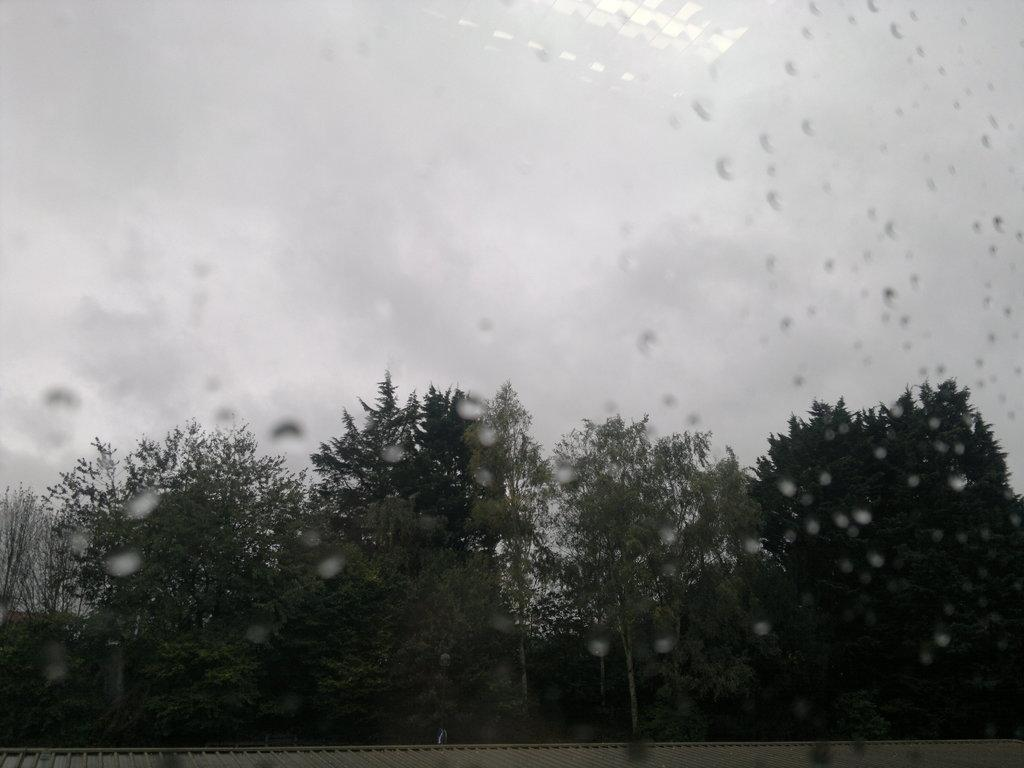What can be seen in abundance in the image? There are many trees in the image. How would you describe the sky in the image? The sky is cloudy in the image. What type of quiver is hanging from the trees in the image? There is no quiver present in the image; it only features trees and a cloudy sky. 